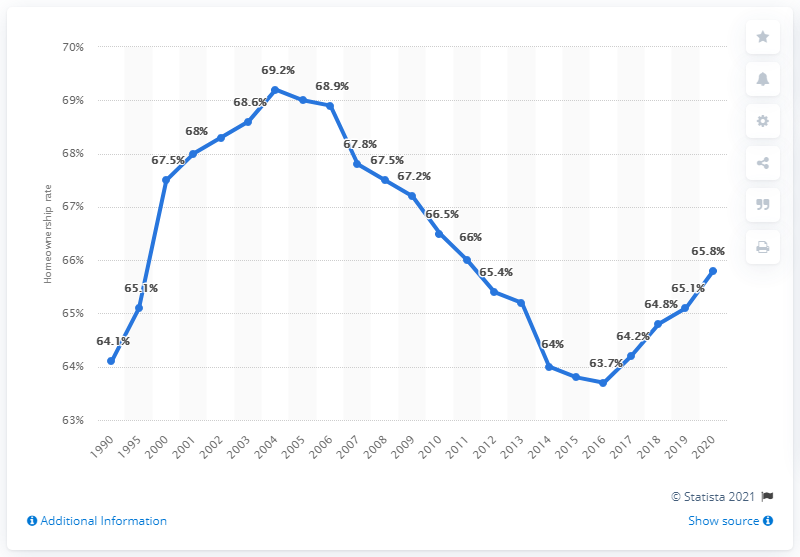Point out several critical features in this image. The homeownership rate reached its peak in 2004. In 2020, the homeownership rate in the United States was 65.8%. The homeownership rate began to increase again in 2016. 